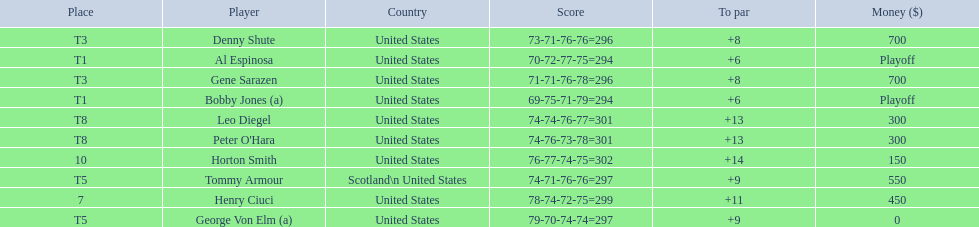Did tommy armour place above or below denny shute? Below. 